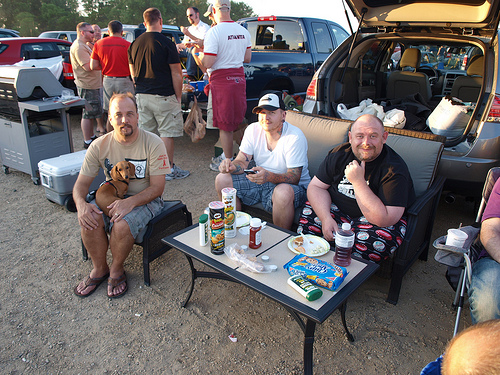<image>
Is the man next to the man? Yes. The man is positioned adjacent to the man, located nearby in the same general area. 